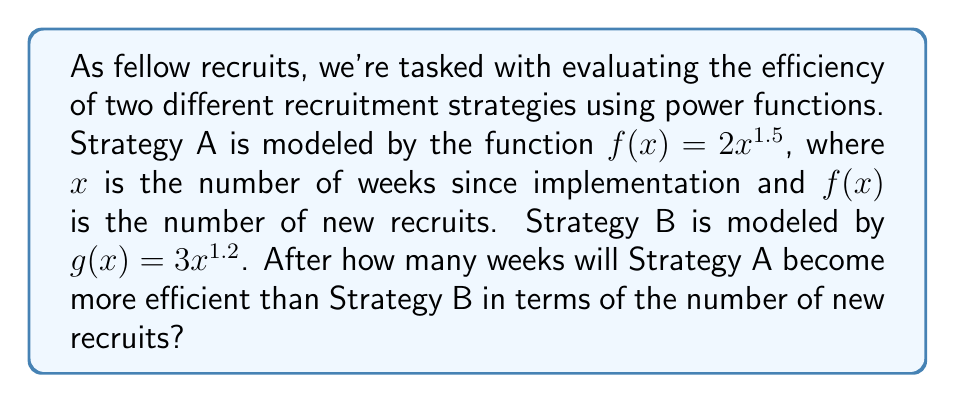Show me your answer to this math problem. To solve this problem, we need to find the point where the two functions intersect. This occurs when $f(x) = g(x)$.

1) Set up the equation:
   $2x^{1.5} = 3x^{1.2}$

2) Divide both sides by $x^{1.2}$:
   $2x^{0.3} = 3$

3) Divide both sides by 2:
   $x^{0.3} = \frac{3}{2}$

4) Take both sides to the power of $\frac{1}{0.3}$:
   $x = (\frac{3}{2})^{\frac{1}{0.3}} \approx 11.0359$

5) Since we're dealing with weeks, we need to round up to the nearest whole number.

Therefore, Strategy A will become more efficient than Strategy B after 12 weeks.

To verify:
At 12 weeks:
$f(12) = 2(12)^{1.5} \approx 83.14$
$g(12) = 3(12)^{1.2} \approx 82.77$

We can see that $f(12) > g(12)$, confirming our result.
Answer: Strategy A will become more efficient than Strategy B after 12 weeks. 